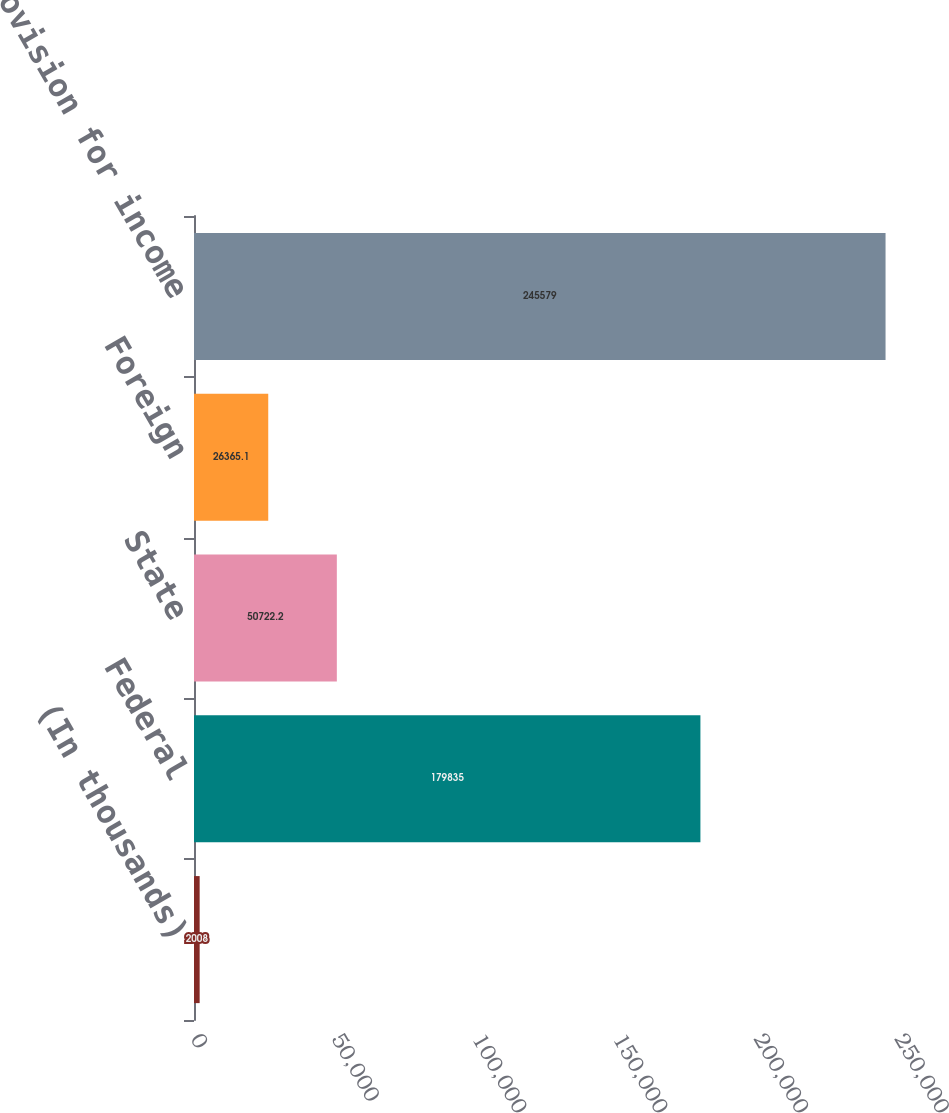Convert chart. <chart><loc_0><loc_0><loc_500><loc_500><bar_chart><fcel>(In thousands)<fcel>Federal<fcel>State<fcel>Foreign<fcel>Total provision for income<nl><fcel>2008<fcel>179835<fcel>50722.2<fcel>26365.1<fcel>245579<nl></chart> 